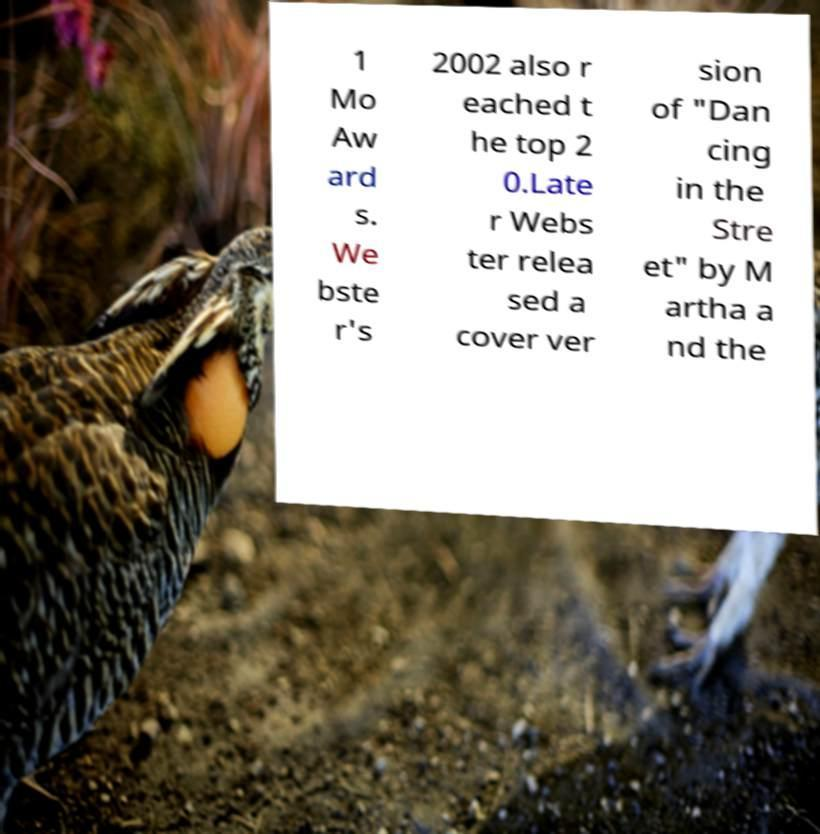Can you accurately transcribe the text from the provided image for me? 1 Mo Aw ard s. We bste r's 2002 also r eached t he top 2 0.Late r Webs ter relea sed a cover ver sion of "Dan cing in the Stre et" by M artha a nd the 